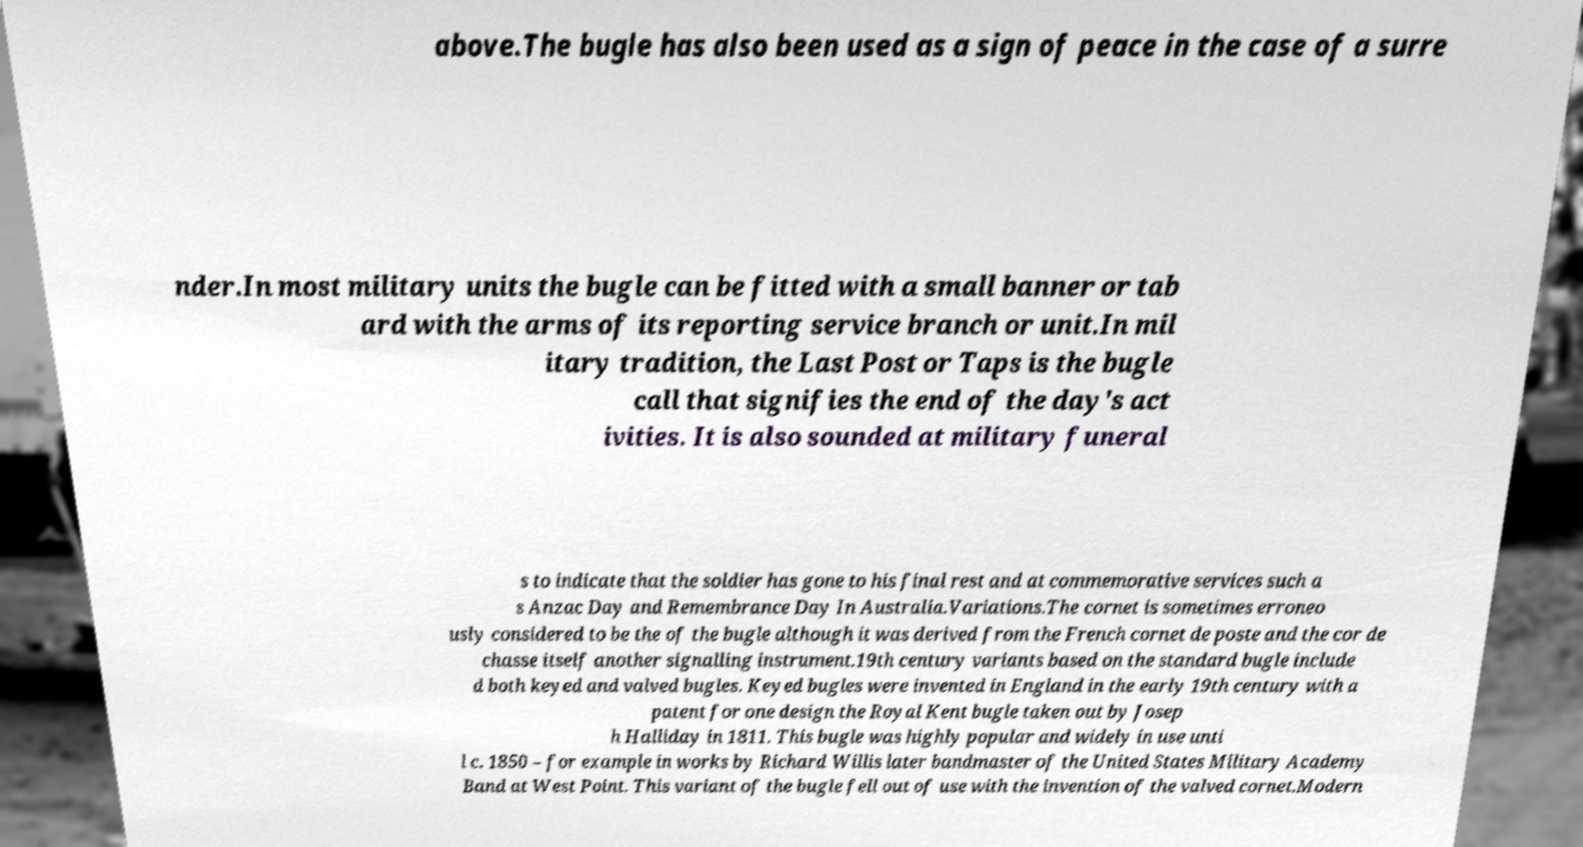I need the written content from this picture converted into text. Can you do that? above.The bugle has also been used as a sign of peace in the case of a surre nder.In most military units the bugle can be fitted with a small banner or tab ard with the arms of its reporting service branch or unit.In mil itary tradition, the Last Post or Taps is the bugle call that signifies the end of the day's act ivities. It is also sounded at military funeral s to indicate that the soldier has gone to his final rest and at commemorative services such a s Anzac Day and Remembrance Day In Australia.Variations.The cornet is sometimes erroneo usly considered to be the of the bugle although it was derived from the French cornet de poste and the cor de chasse itself another signalling instrument.19th century variants based on the standard bugle include d both keyed and valved bugles. Keyed bugles were invented in England in the early 19th century with a patent for one design the Royal Kent bugle taken out by Josep h Halliday in 1811. This bugle was highly popular and widely in use unti l c. 1850 – for example in works by Richard Willis later bandmaster of the United States Military Academy Band at West Point. This variant of the bugle fell out of use with the invention of the valved cornet.Modern 